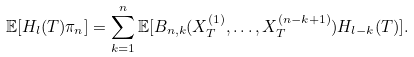Convert formula to latex. <formula><loc_0><loc_0><loc_500><loc_500>\mathbb { E } [ H _ { l } ( T ) \pi _ { n } ] = \sum _ { k = 1 } ^ { n } \mathbb { E } [ B _ { n , k } ( X _ { T } ^ { ( 1 ) } , \dots , X _ { T } ^ { ( n - k + 1 ) } ) H _ { l - k } ( T ) ] .</formula> 